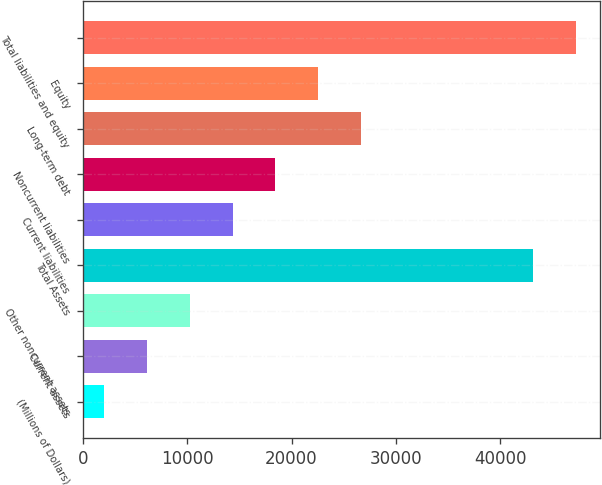<chart> <loc_0><loc_0><loc_500><loc_500><bar_chart><fcel>(Millions of Dollars)<fcel>Current assets<fcel>Other noncurrent assets<fcel>Total Assets<fcel>Current liabilities<fcel>Noncurrent liabilities<fcel>Long-term debt<fcel>Equity<fcel>Total liabilities and equity<nl><fcel>2018<fcel>6127<fcel>10236<fcel>43108<fcel>14345<fcel>18454<fcel>26672<fcel>22563<fcel>47217<nl></chart> 